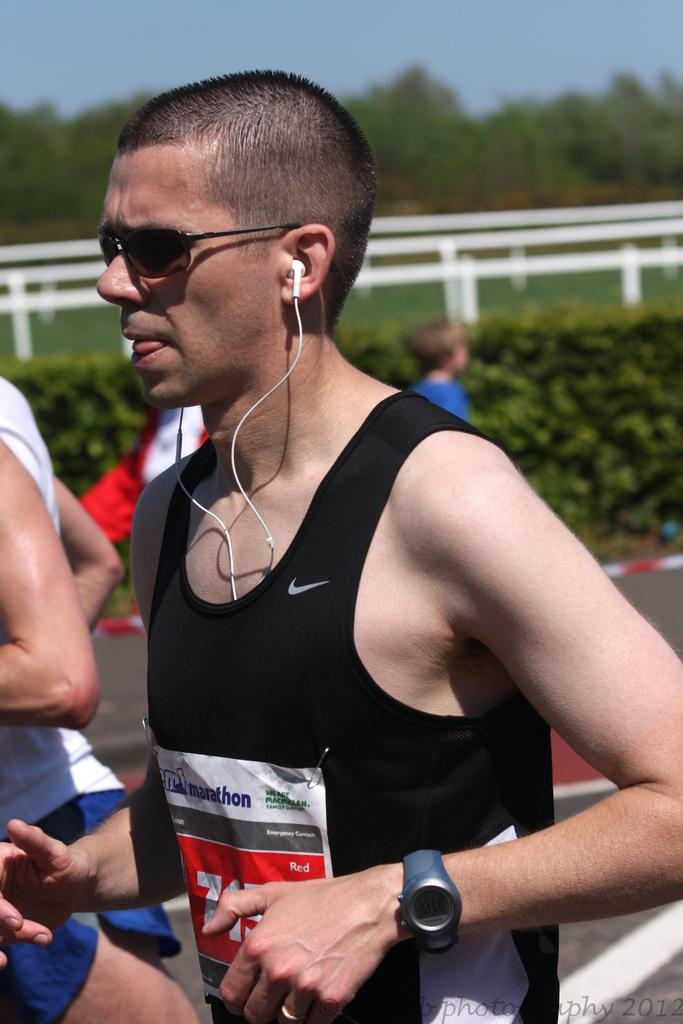What is the man in the image doing? The man is running in the image. What is the man wearing? The man is wearing black clothes and spectacles. What can be seen behind the man? There are people walking behind the man. What type of vegetation is present in the image? There are bushes and trees in the image. What is visible at the top of the image? The sky is visible at the top of the image. What is the smell of the destruction caused by the man in the image? There is no destruction or smell mentioned in the image; the man is simply running. 